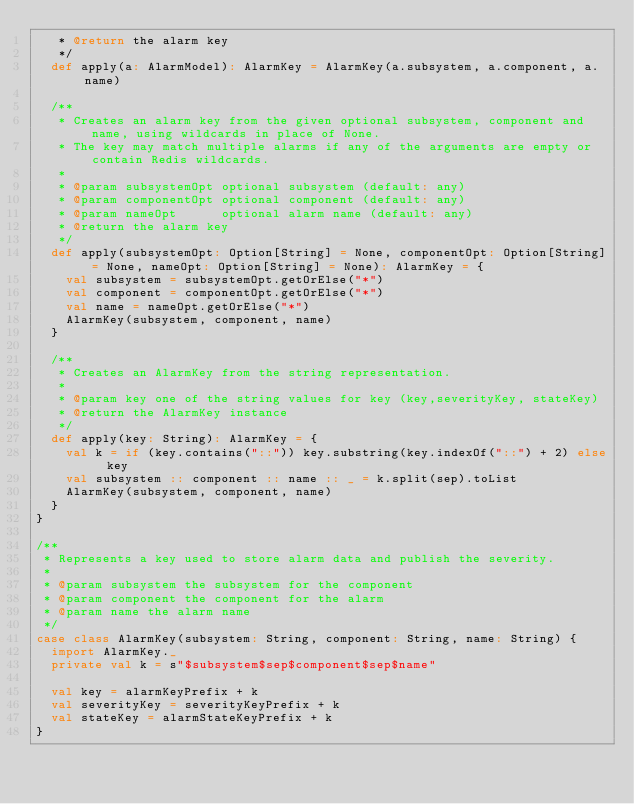<code> <loc_0><loc_0><loc_500><loc_500><_Scala_>   * @return the alarm key
   */
  def apply(a: AlarmModel): AlarmKey = AlarmKey(a.subsystem, a.component, a.name)

  /**
   * Creates an alarm key from the given optional subsystem, component and name, using wildcards in place of None.
   * The key may match multiple alarms if any of the arguments are empty or contain Redis wildcards.
   *
   * @param subsystemOpt optional subsystem (default: any)
   * @param componentOpt optional component (default: any)
   * @param nameOpt      optional alarm name (default: any)
   * @return the alarm key
   */
  def apply(subsystemOpt: Option[String] = None, componentOpt: Option[String] = None, nameOpt: Option[String] = None): AlarmKey = {
    val subsystem = subsystemOpt.getOrElse("*")
    val component = componentOpt.getOrElse("*")
    val name = nameOpt.getOrElse("*")
    AlarmKey(subsystem, component, name)
  }

  /**
   * Creates an AlarmKey from the string representation.
   *
   * @param key one of the string values for key (key,severityKey, stateKey)
   * @return the AlarmKey instance
   */
  def apply(key: String): AlarmKey = {
    val k = if (key.contains("::")) key.substring(key.indexOf("::") + 2) else key
    val subsystem :: component :: name :: _ = k.split(sep).toList
    AlarmKey(subsystem, component, name)
  }
}

/**
 * Represents a key used to store alarm data and publish the severity.
 *
 * @param subsystem the subsystem for the component
 * @param component the component for the alarm
 * @param name the alarm name
 */
case class AlarmKey(subsystem: String, component: String, name: String) {
  import AlarmKey._
  private val k = s"$subsystem$sep$component$sep$name"

  val key = alarmKeyPrefix + k
  val severityKey = severityKeyPrefix + k
  val stateKey = alarmStateKeyPrefix + k
}
</code> 